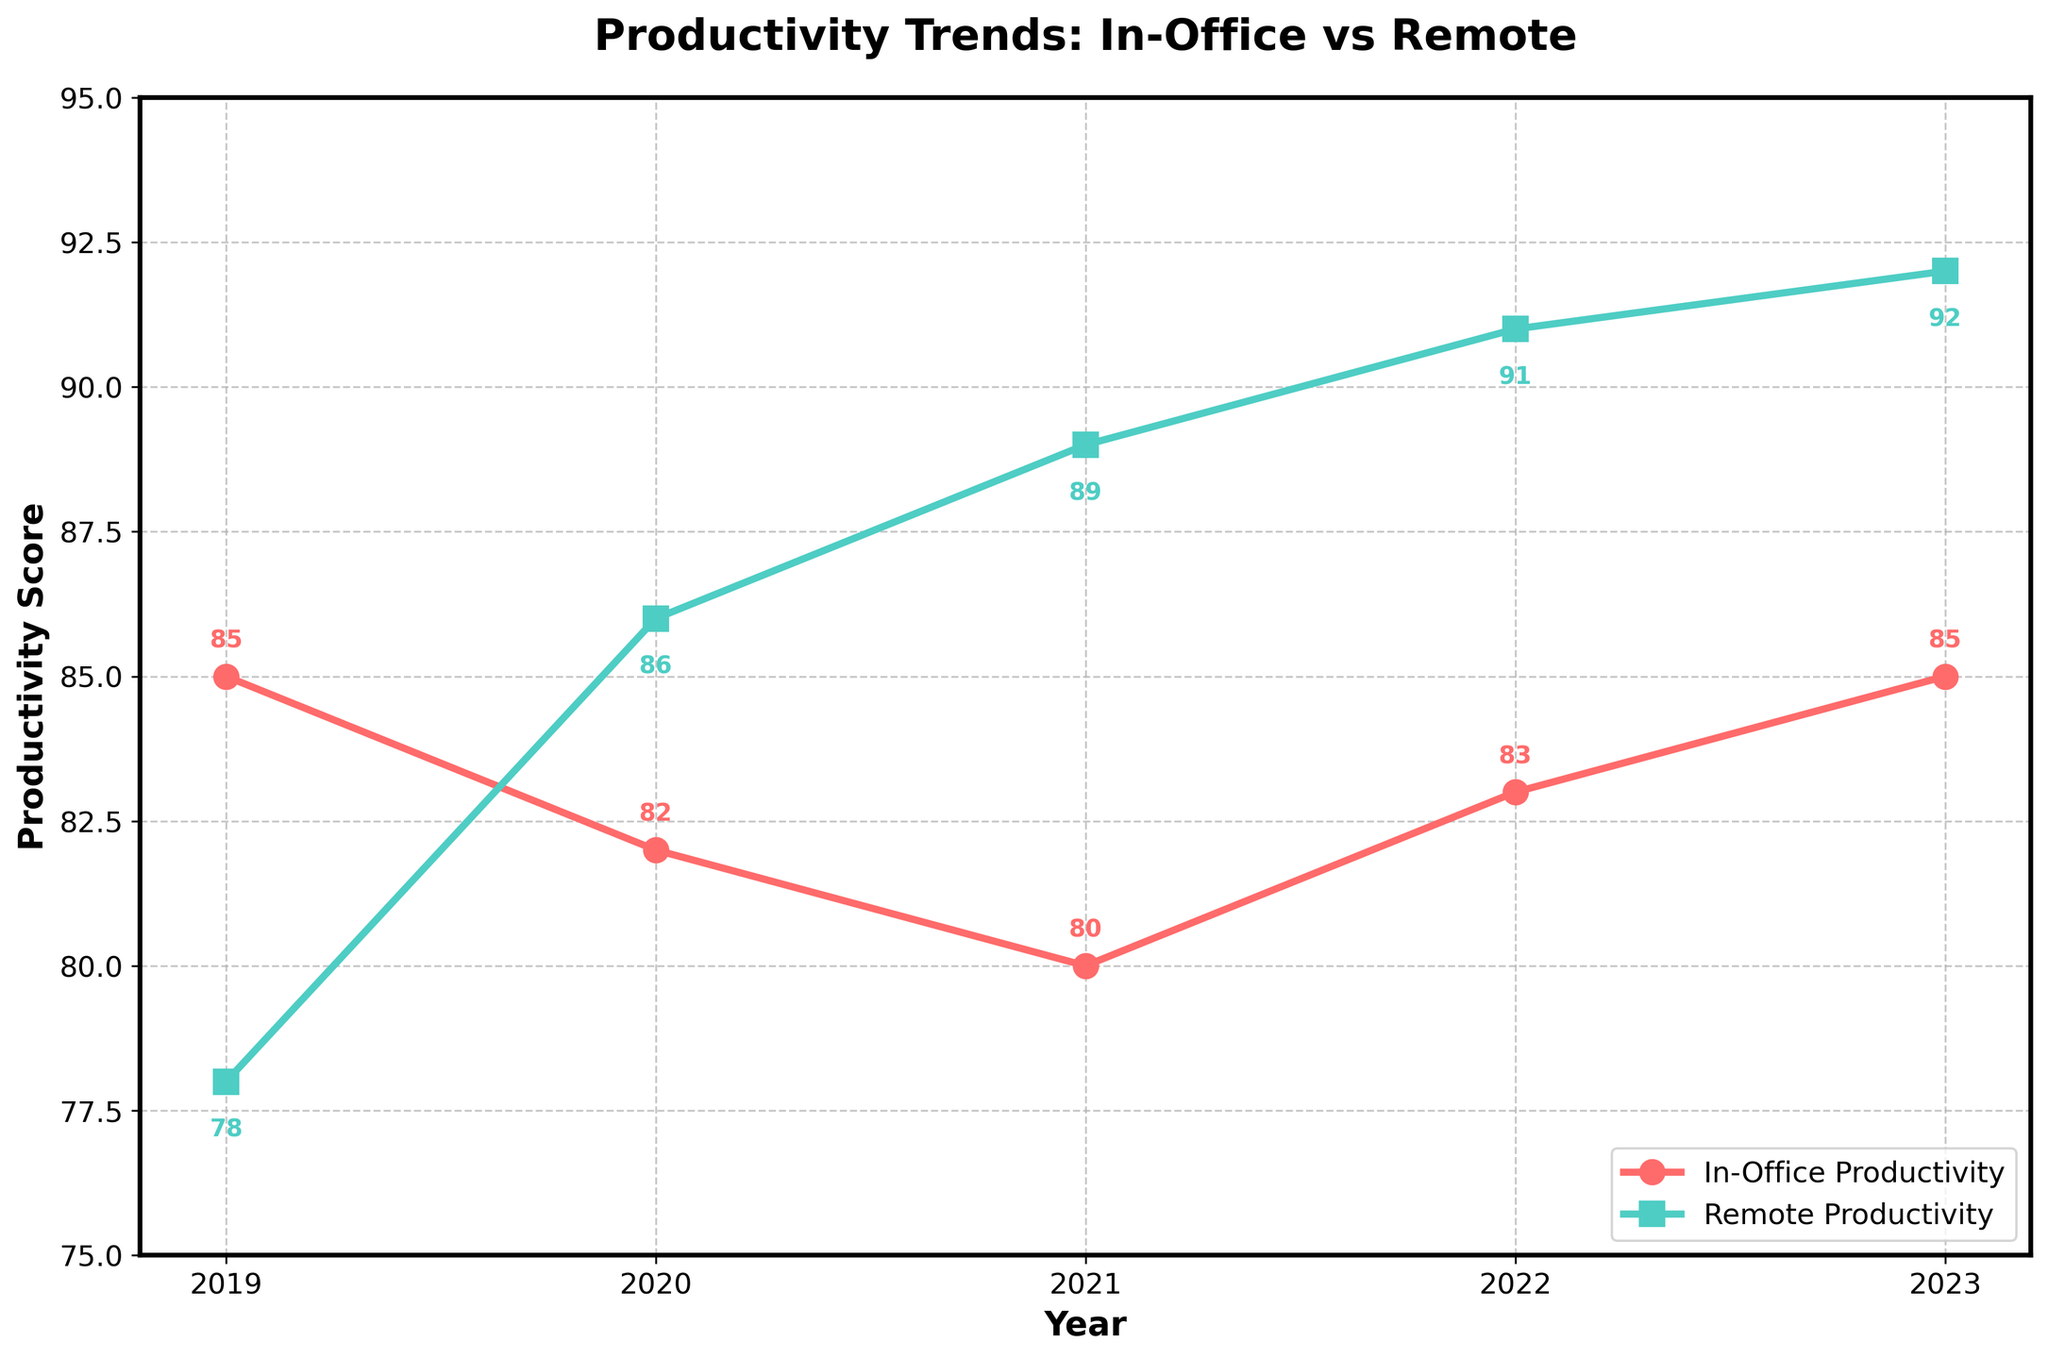What's the trend in remote productivity from 2019 to 2023? To identify the trendline of remote productivity, observe the values marked by squares from 2019 to 2023. Each year, the remote productivity score increases: 78 (2019), 86 (2020), 89 (2021), 91 (2022), and 92 (2023). This shows a consistent upward trend.
Answer: A consistent increase In which year was the in-office and remote productivity closest to each other? Check the gap by comparing the values for both in-office and remote productivity for each year. The smallest difference appears in 2023, where in-office was 85 and remote was 86, a difference of 1.
Answer: 2020 What is the difference in remote productivity between 2019 and 2023? Subtract the remote productivity score in 2019 from the score in 2023. This is calculated as 92 - 78.
Answer: 14 Which productivity type reached higher values over the last five years? Compare the year-wise values for both in-office and remote productivity. Remote productivity values have increased from 78 in 2019 to 92 in 2023, higher than in-office productivity values which range from 80 to 85 in the same period.
Answer: Remote productivity What was the highest productivity score recorded for in-office work? Look at the line marked with circles for in-office productivity scores over the years. The highest value is observed twice, in 2019 and 2023, both being 85.
Answer: 85 In which year did remote productivity have the largest increase compared to the previous year? To find this, calculate the year-on-year differences for remote productivity. The greatest increase is from 78 in 2019 to 86 in 2020, an increase of 8.
Answer: 2020 How does the average in-office productivity from 2019 to 2023 compare with the average remote productivity in the same period? To calculate the averages:
In-office: (85 + 82 + 80 + 83 + 85)/5 = 415/5 = 83
Remote: (78 + 86 + 89 + 91 + 92)/5 = 436/5 = 87.2
Compare the two averages, showing that remote productivity (87.2) is higher than in-office (83).
Answer: Remote is higher by 4.2 points What's the largest productivity score increase for either in-office or remote work from any year to the subsequent year? Compare the year-to-year increases for both productivity types. The largest increase is in remote productivity from 2019 to 2020, increasing by 8 points (86-78).
Answer: Remote productivity in 2020 by 8 points Do in-office or remote productivity scores have more fluctuations over the five-year period? Observe the range of productivity scores for both:
In-office varies between 80 and 85, having a range of 5.
Remote varies between 78 and 92, with a range of 14.
Remote productivity shows greater fluctuation.
Answer: Remote productivity Which productivity type showed a constant increase each year from 2019 to 2023? Examine the plotted lines:
In-office productivity fluctuates, whereas remote productivity consistently increases each year from 78 in 2019 to 92 in 2023.
Answer: Remote productivity 